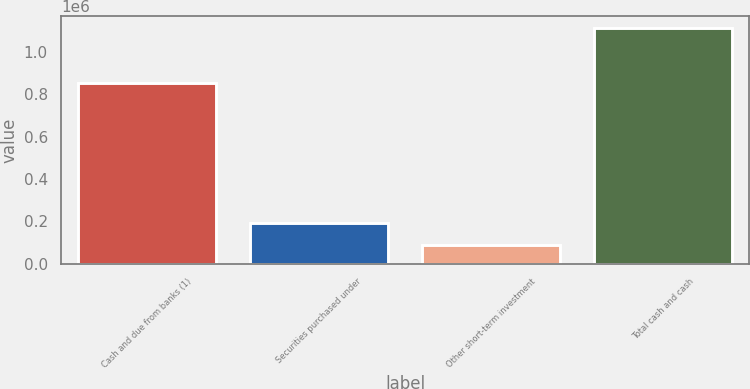<chart> <loc_0><loc_0><loc_500><loc_500><bar_chart><fcel>Cash and due from banks (1)<fcel>Securities purchased under<fcel>Other short-term investment<fcel>Total cash and cash<nl><fcel>852010<fcel>190141<fcel>87385<fcel>1.11495e+06<nl></chart> 